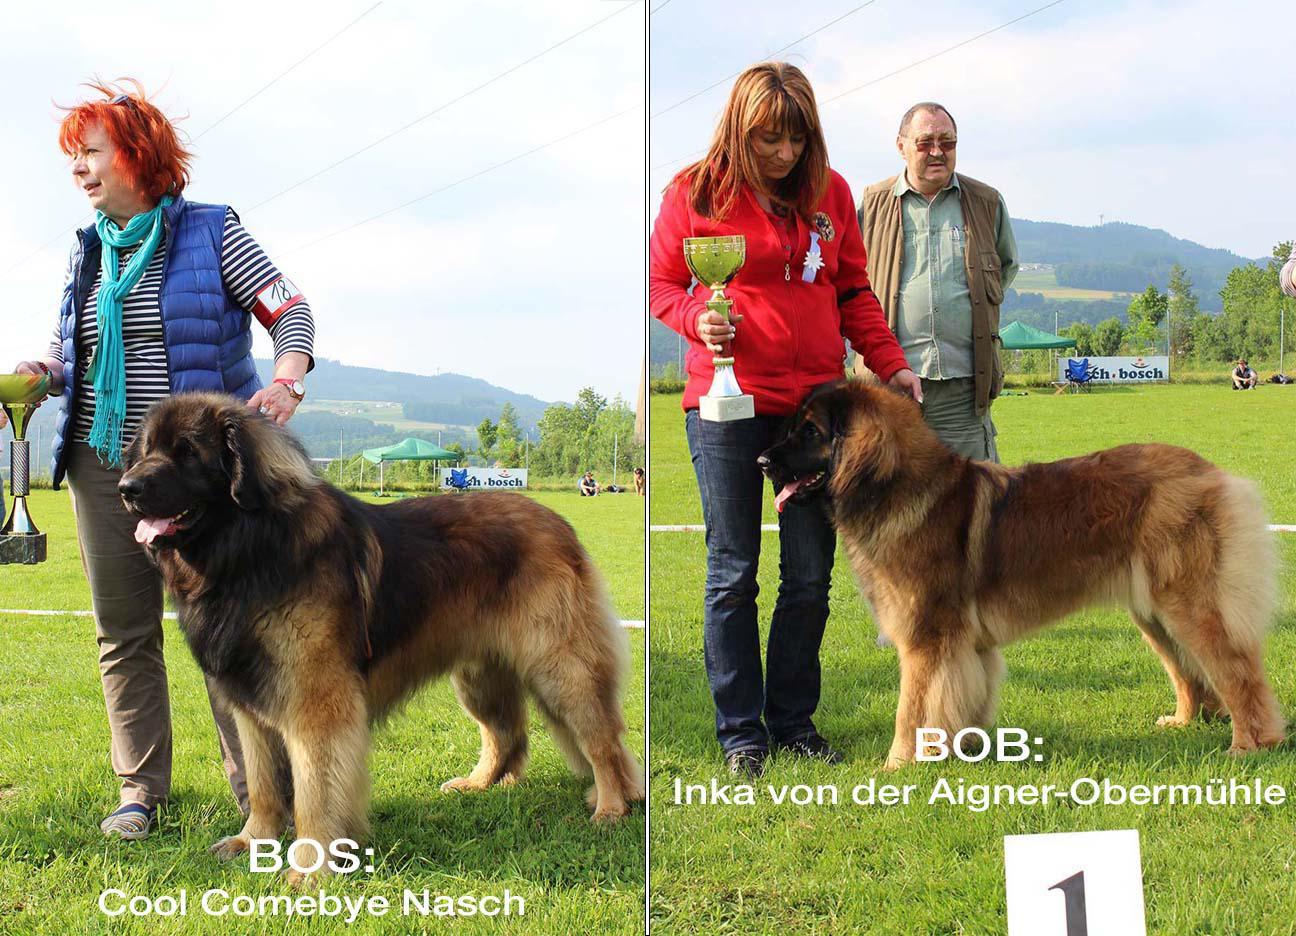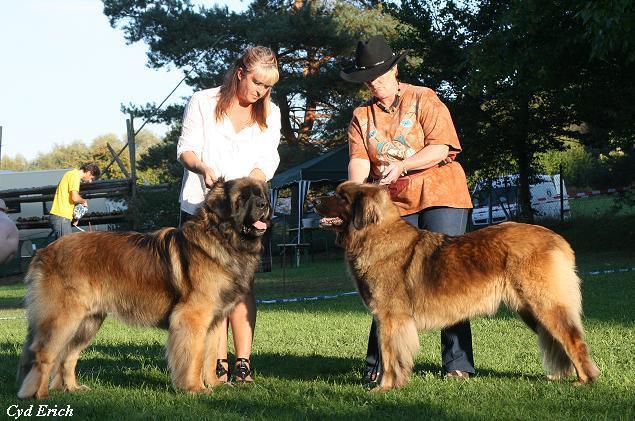The first image is the image on the left, the second image is the image on the right. Assess this claim about the two images: "One of the dogs is alone in one of the pictures.". Correct or not? Answer yes or no. No. 